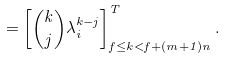<formula> <loc_0><loc_0><loc_500><loc_500>= \left [ \binom { k } { j } \lambda _ { i } ^ { k - j } \right ] ^ { T } _ { f \leq k < f + ( m + 1 ) n } .</formula> 